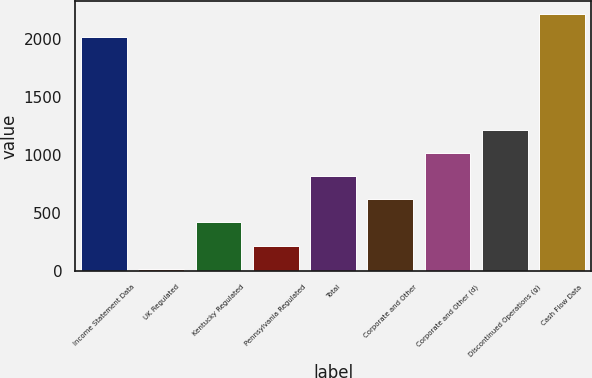Convert chart. <chart><loc_0><loc_0><loc_500><loc_500><bar_chart><fcel>Income Statement Data<fcel>UK Regulated<fcel>Kentucky Regulated<fcel>Pennsylvania Regulated<fcel>Total<fcel>Corporate and Other<fcel>Corporate and Other (d)<fcel>Discontinued Operations (g)<fcel>Cash Flow Data<nl><fcel>2014<fcel>17<fcel>416.4<fcel>216.7<fcel>815.8<fcel>616.1<fcel>1015.5<fcel>1215.2<fcel>2213.7<nl></chart> 